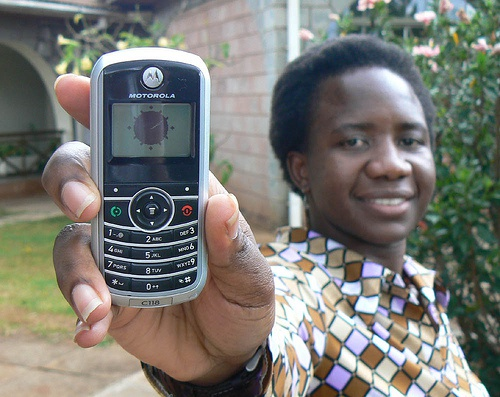Describe the objects in this image and their specific colors. I can see people in lightgray, gray, white, and black tones, cell phone in lightgray, black, gray, navy, and white tones, and clock in lightgray, gray, and black tones in this image. 